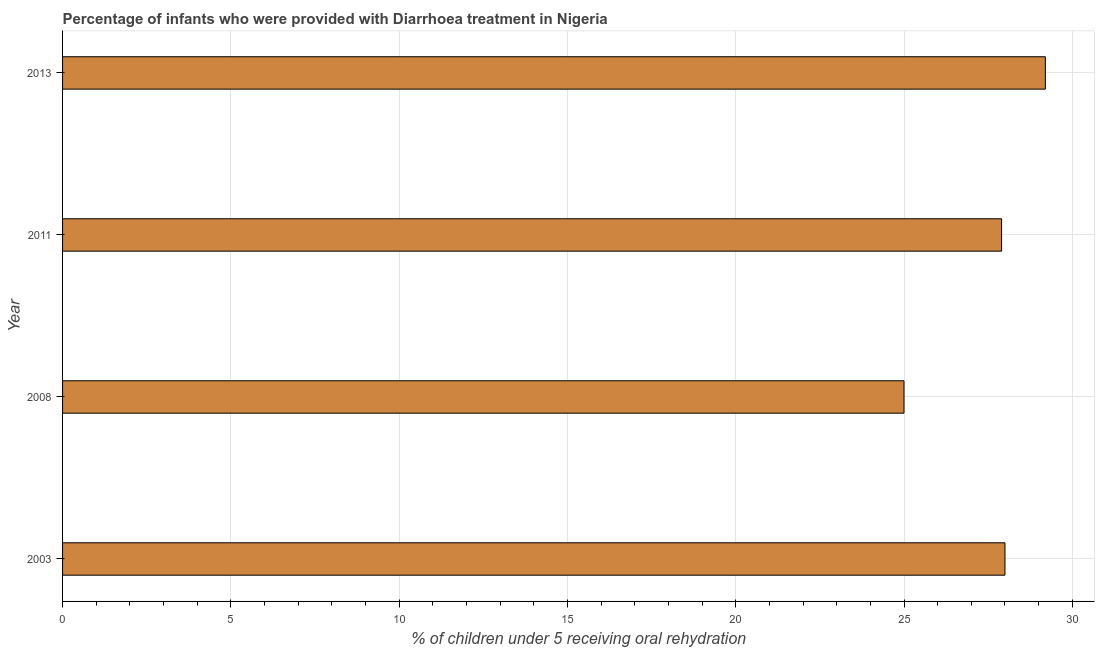Does the graph contain grids?
Give a very brief answer. Yes. What is the title of the graph?
Offer a terse response. Percentage of infants who were provided with Diarrhoea treatment in Nigeria. What is the label or title of the X-axis?
Your answer should be compact. % of children under 5 receiving oral rehydration. What is the percentage of children who were provided with treatment diarrhoea in 2011?
Offer a very short reply. 27.9. Across all years, what is the maximum percentage of children who were provided with treatment diarrhoea?
Your answer should be very brief. 29.2. In which year was the percentage of children who were provided with treatment diarrhoea maximum?
Offer a terse response. 2013. In which year was the percentage of children who were provided with treatment diarrhoea minimum?
Keep it short and to the point. 2008. What is the sum of the percentage of children who were provided with treatment diarrhoea?
Make the answer very short. 110.1. What is the difference between the percentage of children who were provided with treatment diarrhoea in 2003 and 2011?
Keep it short and to the point. 0.1. What is the average percentage of children who were provided with treatment diarrhoea per year?
Make the answer very short. 27.52. What is the median percentage of children who were provided with treatment diarrhoea?
Your answer should be compact. 27.95. In how many years, is the percentage of children who were provided with treatment diarrhoea greater than 12 %?
Give a very brief answer. 4. Do a majority of the years between 2008 and 2013 (inclusive) have percentage of children who were provided with treatment diarrhoea greater than 18 %?
Your response must be concise. Yes. Is the difference between the percentage of children who were provided with treatment diarrhoea in 2008 and 2013 greater than the difference between any two years?
Make the answer very short. Yes. What is the difference between the highest and the second highest percentage of children who were provided with treatment diarrhoea?
Keep it short and to the point. 1.2. Is the sum of the percentage of children who were provided with treatment diarrhoea in 2003 and 2013 greater than the maximum percentage of children who were provided with treatment diarrhoea across all years?
Ensure brevity in your answer.  Yes. What is the difference between the highest and the lowest percentage of children who were provided with treatment diarrhoea?
Keep it short and to the point. 4.2. How many bars are there?
Your answer should be very brief. 4. Are all the bars in the graph horizontal?
Make the answer very short. Yes. How many years are there in the graph?
Your answer should be very brief. 4. What is the % of children under 5 receiving oral rehydration of 2011?
Offer a very short reply. 27.9. What is the % of children under 5 receiving oral rehydration of 2013?
Provide a succinct answer. 29.2. What is the difference between the % of children under 5 receiving oral rehydration in 2003 and 2008?
Offer a terse response. 3. What is the difference between the % of children under 5 receiving oral rehydration in 2003 and 2013?
Offer a very short reply. -1.2. What is the difference between the % of children under 5 receiving oral rehydration in 2008 and 2013?
Keep it short and to the point. -4.2. What is the ratio of the % of children under 5 receiving oral rehydration in 2003 to that in 2008?
Provide a short and direct response. 1.12. What is the ratio of the % of children under 5 receiving oral rehydration in 2008 to that in 2011?
Offer a terse response. 0.9. What is the ratio of the % of children under 5 receiving oral rehydration in 2008 to that in 2013?
Provide a succinct answer. 0.86. What is the ratio of the % of children under 5 receiving oral rehydration in 2011 to that in 2013?
Offer a very short reply. 0.95. 